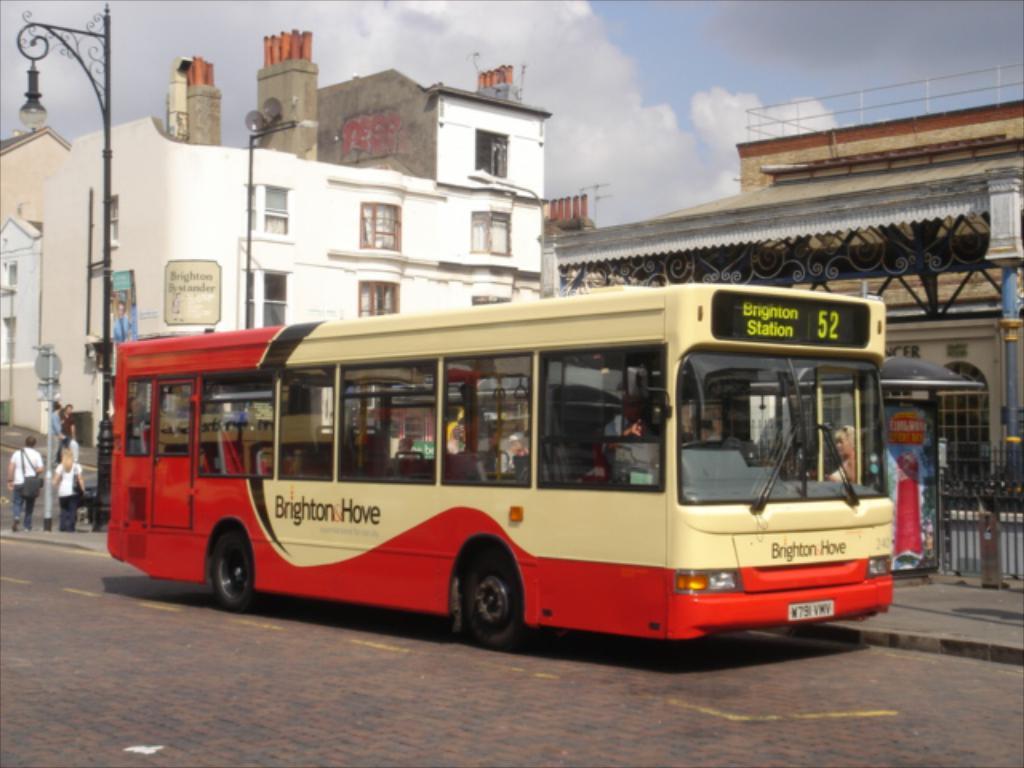What 2 numbers are on the bus marquee?
Provide a short and direct response. 52. Where is bus going?
Keep it short and to the point. Brighton station. 